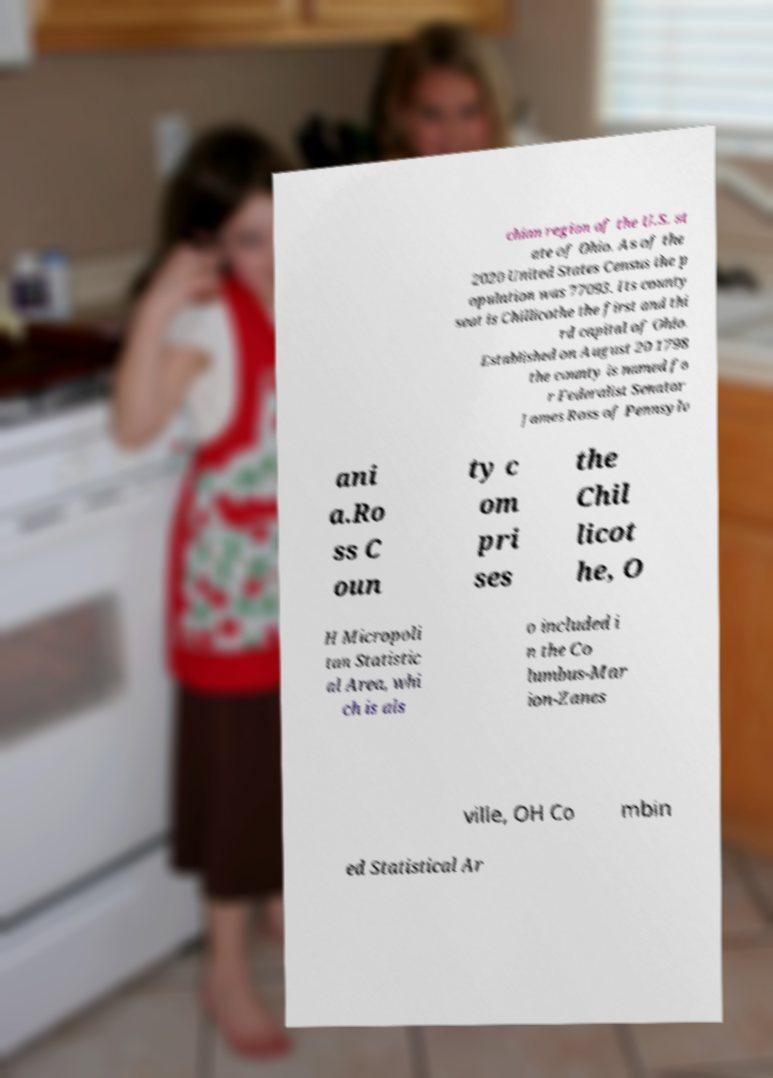What messages or text are displayed in this image? I need them in a readable, typed format. chian region of the U.S. st ate of Ohio. As of the 2020 United States Census the p opulation was 77093. Its county seat is Chillicothe the first and thi rd capital of Ohio. Established on August 20 1798 the county is named fo r Federalist Senator James Ross of Pennsylv ani a.Ro ss C oun ty c om pri ses the Chil licot he, O H Micropoli tan Statistic al Area, whi ch is als o included i n the Co lumbus-Mar ion-Zanes ville, OH Co mbin ed Statistical Ar 